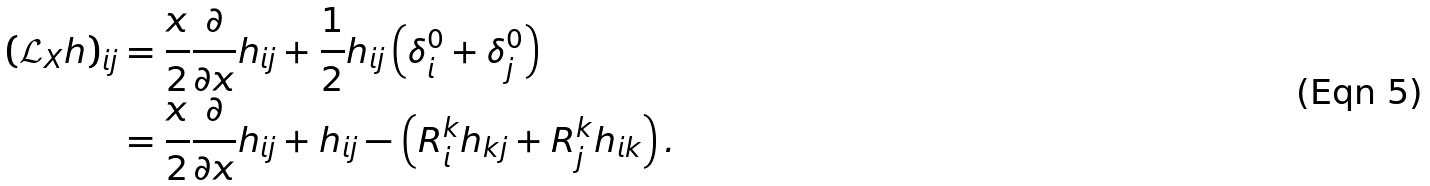<formula> <loc_0><loc_0><loc_500><loc_500>\left ( \mathcal { L } _ { X } h \right ) _ { i j } & = \frac { x } { 2 } \frac { \partial } { \partial x } h _ { i j } + \frac { 1 } { 2 } h _ { i j } \left ( \delta _ { i } ^ { 0 } + \delta _ { j } ^ { 0 } \right ) \\ & = \frac { x } { 2 } \frac { \partial } { \partial x } h _ { i j } + h _ { i j } - \left ( R _ { i } ^ { k } h _ { k j } + R _ { j } ^ { k } h _ { i k } \right ) .</formula> 